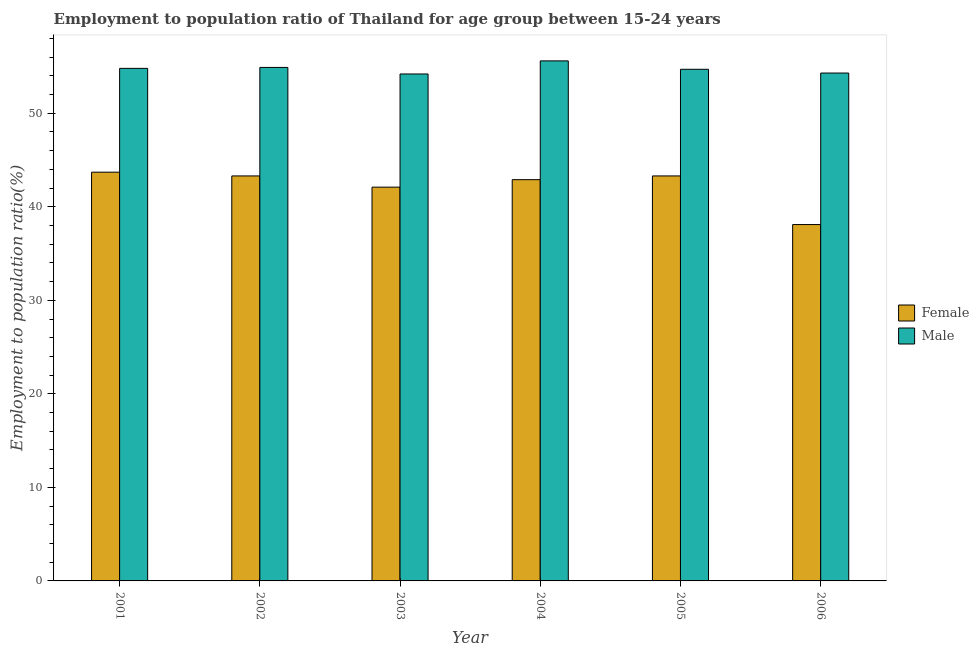How many different coloured bars are there?
Your answer should be compact. 2. Are the number of bars per tick equal to the number of legend labels?
Keep it short and to the point. Yes. How many bars are there on the 5th tick from the left?
Provide a succinct answer. 2. How many bars are there on the 1st tick from the right?
Make the answer very short. 2. What is the label of the 3rd group of bars from the left?
Your answer should be compact. 2003. What is the employment to population ratio(female) in 2005?
Offer a terse response. 43.3. Across all years, what is the maximum employment to population ratio(male)?
Provide a succinct answer. 55.6. Across all years, what is the minimum employment to population ratio(female)?
Offer a very short reply. 38.1. In which year was the employment to population ratio(male) minimum?
Offer a very short reply. 2003. What is the total employment to population ratio(female) in the graph?
Keep it short and to the point. 253.4. What is the difference between the employment to population ratio(male) in 2001 and that in 2005?
Provide a short and direct response. 0.1. What is the difference between the employment to population ratio(male) in 2001 and the employment to population ratio(female) in 2004?
Your answer should be very brief. -0.8. What is the average employment to population ratio(male) per year?
Offer a very short reply. 54.75. In how many years, is the employment to population ratio(female) greater than 52 %?
Give a very brief answer. 0. What is the ratio of the employment to population ratio(male) in 2003 to that in 2004?
Make the answer very short. 0.97. Is the employment to population ratio(male) in 2001 less than that in 2003?
Your answer should be very brief. No. Is the difference between the employment to population ratio(male) in 2002 and 2006 greater than the difference between the employment to population ratio(female) in 2002 and 2006?
Ensure brevity in your answer.  No. What is the difference between the highest and the second highest employment to population ratio(male)?
Keep it short and to the point. 0.7. What is the difference between the highest and the lowest employment to population ratio(female)?
Offer a terse response. 5.6. In how many years, is the employment to population ratio(male) greater than the average employment to population ratio(male) taken over all years?
Give a very brief answer. 3. How many bars are there?
Your answer should be compact. 12. Are all the bars in the graph horizontal?
Offer a terse response. No. What is the difference between two consecutive major ticks on the Y-axis?
Provide a succinct answer. 10. Are the values on the major ticks of Y-axis written in scientific E-notation?
Make the answer very short. No. How many legend labels are there?
Provide a short and direct response. 2. How are the legend labels stacked?
Provide a succinct answer. Vertical. What is the title of the graph?
Give a very brief answer. Employment to population ratio of Thailand for age group between 15-24 years. What is the Employment to population ratio(%) of Female in 2001?
Give a very brief answer. 43.7. What is the Employment to population ratio(%) in Male in 2001?
Keep it short and to the point. 54.8. What is the Employment to population ratio(%) in Female in 2002?
Ensure brevity in your answer.  43.3. What is the Employment to population ratio(%) of Male in 2002?
Keep it short and to the point. 54.9. What is the Employment to population ratio(%) of Female in 2003?
Your response must be concise. 42.1. What is the Employment to population ratio(%) of Male in 2003?
Your answer should be very brief. 54.2. What is the Employment to population ratio(%) of Female in 2004?
Keep it short and to the point. 42.9. What is the Employment to population ratio(%) in Male in 2004?
Provide a short and direct response. 55.6. What is the Employment to population ratio(%) in Female in 2005?
Offer a very short reply. 43.3. What is the Employment to population ratio(%) in Male in 2005?
Your answer should be very brief. 54.7. What is the Employment to population ratio(%) of Female in 2006?
Provide a succinct answer. 38.1. What is the Employment to population ratio(%) in Male in 2006?
Your answer should be compact. 54.3. Across all years, what is the maximum Employment to population ratio(%) of Female?
Your answer should be compact. 43.7. Across all years, what is the maximum Employment to population ratio(%) of Male?
Your answer should be compact. 55.6. Across all years, what is the minimum Employment to population ratio(%) of Female?
Give a very brief answer. 38.1. Across all years, what is the minimum Employment to population ratio(%) of Male?
Provide a short and direct response. 54.2. What is the total Employment to population ratio(%) of Female in the graph?
Make the answer very short. 253.4. What is the total Employment to population ratio(%) of Male in the graph?
Give a very brief answer. 328.5. What is the difference between the Employment to population ratio(%) in Male in 2001 and that in 2002?
Provide a succinct answer. -0.1. What is the difference between the Employment to population ratio(%) in Female in 2001 and that in 2003?
Give a very brief answer. 1.6. What is the difference between the Employment to population ratio(%) in Female in 2001 and that in 2005?
Your answer should be very brief. 0.4. What is the difference between the Employment to population ratio(%) in Male in 2001 and that in 2005?
Offer a terse response. 0.1. What is the difference between the Employment to population ratio(%) in Female in 2001 and that in 2006?
Your answer should be compact. 5.6. What is the difference between the Employment to population ratio(%) in Male in 2001 and that in 2006?
Your response must be concise. 0.5. What is the difference between the Employment to population ratio(%) of Male in 2002 and that in 2003?
Make the answer very short. 0.7. What is the difference between the Employment to population ratio(%) in Female in 2002 and that in 2004?
Your answer should be compact. 0.4. What is the difference between the Employment to population ratio(%) in Male in 2002 and that in 2004?
Provide a short and direct response. -0.7. What is the difference between the Employment to population ratio(%) in Female in 2002 and that in 2005?
Give a very brief answer. 0. What is the difference between the Employment to population ratio(%) in Female in 2002 and that in 2006?
Your answer should be compact. 5.2. What is the difference between the Employment to population ratio(%) of Female in 2003 and that in 2004?
Your response must be concise. -0.8. What is the difference between the Employment to population ratio(%) of Female in 2003 and that in 2005?
Keep it short and to the point. -1.2. What is the difference between the Employment to population ratio(%) of Female in 2003 and that in 2006?
Provide a short and direct response. 4. What is the difference between the Employment to population ratio(%) of Female in 2004 and that in 2005?
Your answer should be very brief. -0.4. What is the difference between the Employment to population ratio(%) of Male in 2004 and that in 2005?
Your response must be concise. 0.9. What is the difference between the Employment to population ratio(%) in Male in 2004 and that in 2006?
Provide a succinct answer. 1.3. What is the difference between the Employment to population ratio(%) in Female in 2001 and the Employment to population ratio(%) in Male in 2004?
Provide a succinct answer. -11.9. What is the difference between the Employment to population ratio(%) in Female in 2002 and the Employment to population ratio(%) in Male in 2004?
Your answer should be compact. -12.3. What is the difference between the Employment to population ratio(%) of Female in 2002 and the Employment to population ratio(%) of Male in 2005?
Give a very brief answer. -11.4. What is the difference between the Employment to population ratio(%) of Female in 2002 and the Employment to population ratio(%) of Male in 2006?
Provide a short and direct response. -11. What is the difference between the Employment to population ratio(%) in Female in 2003 and the Employment to population ratio(%) in Male in 2005?
Your answer should be very brief. -12.6. What is the difference between the Employment to population ratio(%) of Female in 2003 and the Employment to population ratio(%) of Male in 2006?
Your answer should be very brief. -12.2. What is the difference between the Employment to population ratio(%) of Female in 2004 and the Employment to population ratio(%) of Male in 2006?
Your answer should be compact. -11.4. What is the difference between the Employment to population ratio(%) in Female in 2005 and the Employment to population ratio(%) in Male in 2006?
Offer a very short reply. -11. What is the average Employment to population ratio(%) in Female per year?
Provide a short and direct response. 42.23. What is the average Employment to population ratio(%) in Male per year?
Make the answer very short. 54.75. In the year 2002, what is the difference between the Employment to population ratio(%) of Female and Employment to population ratio(%) of Male?
Give a very brief answer. -11.6. In the year 2006, what is the difference between the Employment to population ratio(%) in Female and Employment to population ratio(%) in Male?
Your answer should be very brief. -16.2. What is the ratio of the Employment to population ratio(%) in Female in 2001 to that in 2002?
Keep it short and to the point. 1.01. What is the ratio of the Employment to population ratio(%) in Male in 2001 to that in 2002?
Provide a short and direct response. 1. What is the ratio of the Employment to population ratio(%) in Female in 2001 to that in 2003?
Provide a succinct answer. 1.04. What is the ratio of the Employment to population ratio(%) in Male in 2001 to that in 2003?
Your answer should be compact. 1.01. What is the ratio of the Employment to population ratio(%) in Female in 2001 to that in 2004?
Your response must be concise. 1.02. What is the ratio of the Employment to population ratio(%) in Male in 2001 to that in 2004?
Make the answer very short. 0.99. What is the ratio of the Employment to population ratio(%) in Female in 2001 to that in 2005?
Ensure brevity in your answer.  1.01. What is the ratio of the Employment to population ratio(%) in Male in 2001 to that in 2005?
Offer a very short reply. 1. What is the ratio of the Employment to population ratio(%) in Female in 2001 to that in 2006?
Your answer should be compact. 1.15. What is the ratio of the Employment to population ratio(%) of Male in 2001 to that in 2006?
Your response must be concise. 1.01. What is the ratio of the Employment to population ratio(%) in Female in 2002 to that in 2003?
Offer a very short reply. 1.03. What is the ratio of the Employment to population ratio(%) of Male in 2002 to that in 2003?
Provide a succinct answer. 1.01. What is the ratio of the Employment to population ratio(%) in Female in 2002 to that in 2004?
Provide a succinct answer. 1.01. What is the ratio of the Employment to population ratio(%) in Male in 2002 to that in 2004?
Keep it short and to the point. 0.99. What is the ratio of the Employment to population ratio(%) in Male in 2002 to that in 2005?
Ensure brevity in your answer.  1. What is the ratio of the Employment to population ratio(%) in Female in 2002 to that in 2006?
Offer a very short reply. 1.14. What is the ratio of the Employment to population ratio(%) of Male in 2002 to that in 2006?
Ensure brevity in your answer.  1.01. What is the ratio of the Employment to population ratio(%) in Female in 2003 to that in 2004?
Keep it short and to the point. 0.98. What is the ratio of the Employment to population ratio(%) in Male in 2003 to that in 2004?
Offer a terse response. 0.97. What is the ratio of the Employment to population ratio(%) of Female in 2003 to that in 2005?
Your answer should be compact. 0.97. What is the ratio of the Employment to population ratio(%) in Male in 2003 to that in 2005?
Keep it short and to the point. 0.99. What is the ratio of the Employment to population ratio(%) of Female in 2003 to that in 2006?
Give a very brief answer. 1.1. What is the ratio of the Employment to population ratio(%) in Male in 2003 to that in 2006?
Your answer should be compact. 1. What is the ratio of the Employment to population ratio(%) of Female in 2004 to that in 2005?
Your answer should be very brief. 0.99. What is the ratio of the Employment to population ratio(%) in Male in 2004 to that in 2005?
Make the answer very short. 1.02. What is the ratio of the Employment to population ratio(%) of Female in 2004 to that in 2006?
Offer a very short reply. 1.13. What is the ratio of the Employment to population ratio(%) of Male in 2004 to that in 2006?
Your answer should be compact. 1.02. What is the ratio of the Employment to population ratio(%) of Female in 2005 to that in 2006?
Provide a succinct answer. 1.14. What is the ratio of the Employment to population ratio(%) of Male in 2005 to that in 2006?
Provide a succinct answer. 1.01. What is the difference between the highest and the second highest Employment to population ratio(%) of Female?
Offer a terse response. 0.4. What is the difference between the highest and the lowest Employment to population ratio(%) in Male?
Provide a short and direct response. 1.4. 